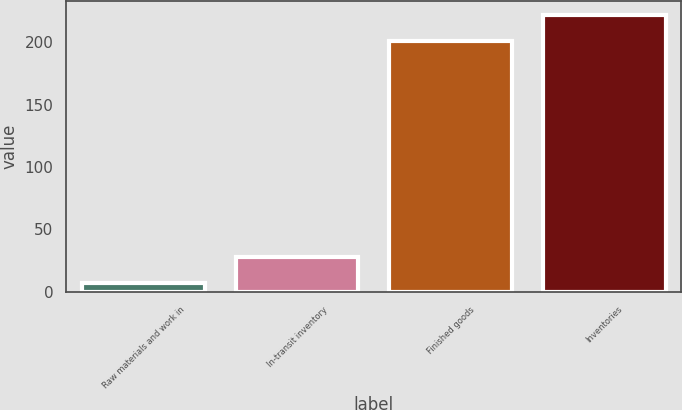<chart> <loc_0><loc_0><loc_500><loc_500><bar_chart><fcel>Raw materials and work in<fcel>In-transit inventory<fcel>Finished goods<fcel>Inventories<nl><fcel>7<fcel>28<fcel>201<fcel>222<nl></chart> 